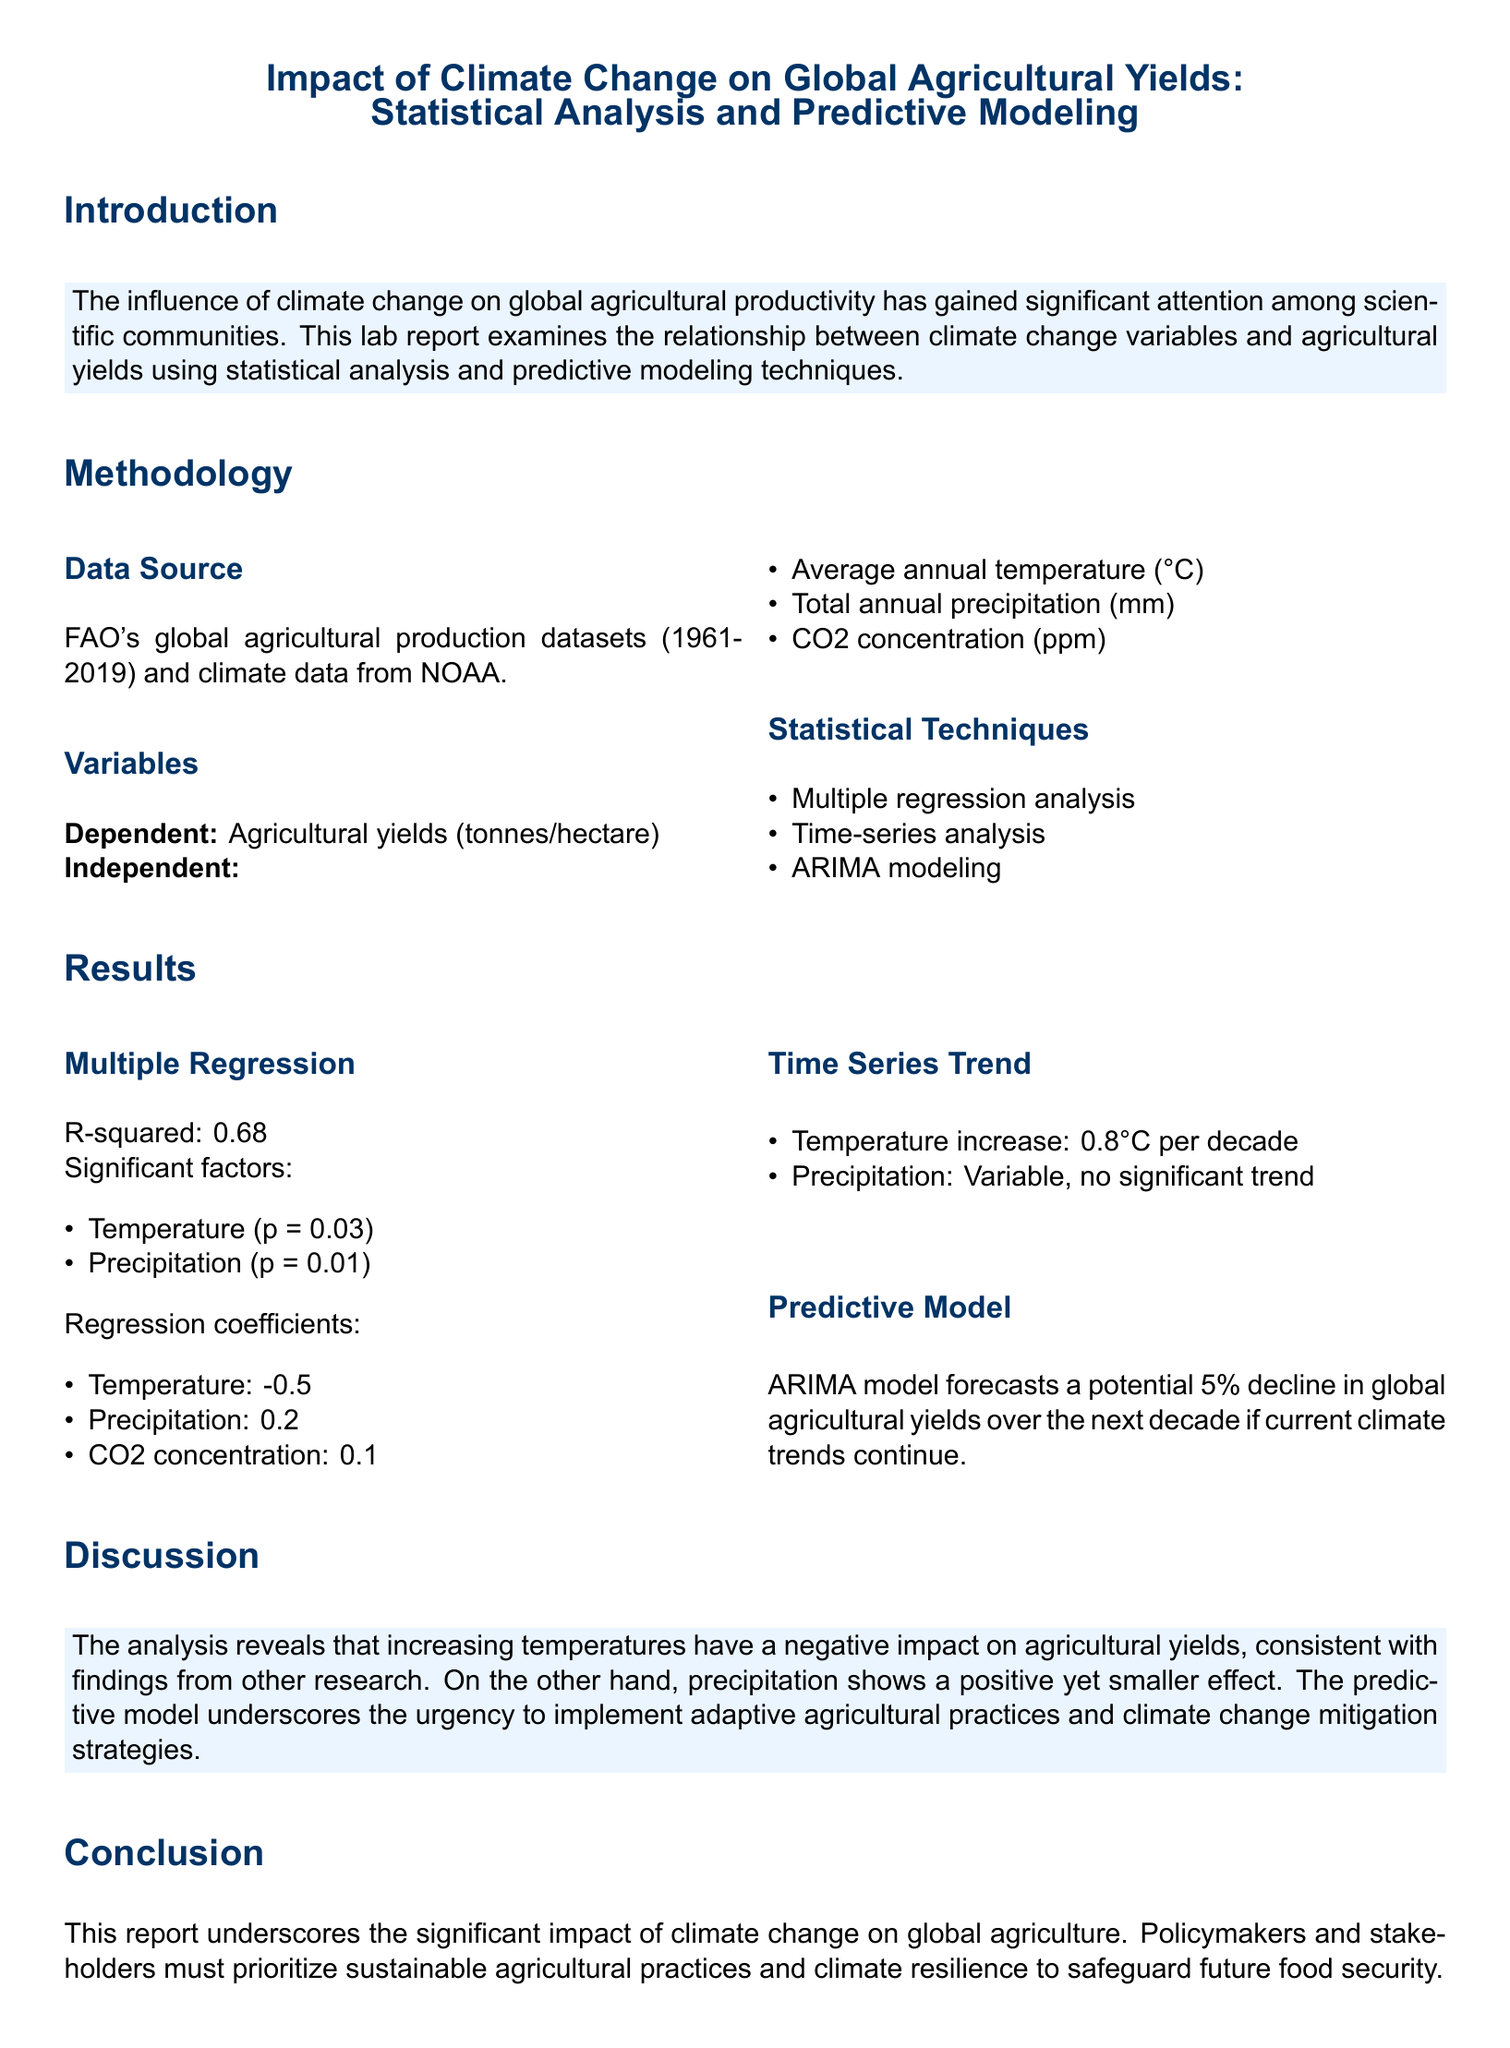What is the title of the report? The title of the report is a key heading that summarizes the main focus of the document.
Answer: Impact of Climate Change on Global Agricultural Yields: Statistical Analysis and Predictive Modeling What is the dependent variable in the study? The dependent variable is the measure that is being tested and is affected by independent variables.
Answer: Agricultural yields (tonnes/hectare) What is the R-squared value obtained from the multiple regression analysis? The R-squared value indicates how well the independent variables explain the variability of the dependent variable.
Answer: 0.68 What are the significant factors affecting agricultural yields according to the multiple regression analysis? The report lists specific significant factors along with their p-values in the regression.
Answer: Temperature and Precipitation What is the forecasted decline in global agricultural yields according to the predictive model? The report discusses future trends and anticipated changes based on the predictive modeling techniques used.
Answer: 5% What is the temperature increase per decade noted in the time series trend analysis? This information indicates the rate of temperature rise which affects agricultural productivity over time.
Answer: 0.8°C What does the analysis suggest regarding precipitation? The role of precipitation in the context of agricultural yields is analyzed to understand its impact.
Answer: Variable, no significant trend Which organization provided the global agricultural production datasets? This information pertains to the source of data and its credibility in the research.
Answer: FAO What is the main conclusion of the report? The conclusion summarizes the primary findings and recommendations of the study.
Answer: Significant impact of climate change on global agriculture 